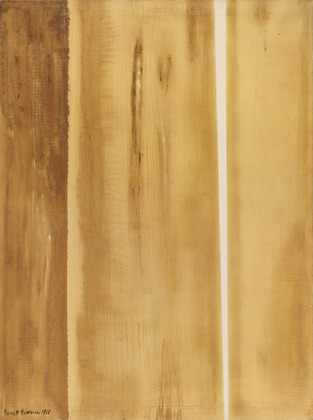What emotions does this painting evoke for you? The painting evokes a sense of calm and contemplation. The warm, earthy hues provide a grounding and comforting feel, while the vertical lines create an impression of stability and order. Despite their rough texture, the lines suggest a sense of structure amidst natural chaos, evoking introspection and reflection. 